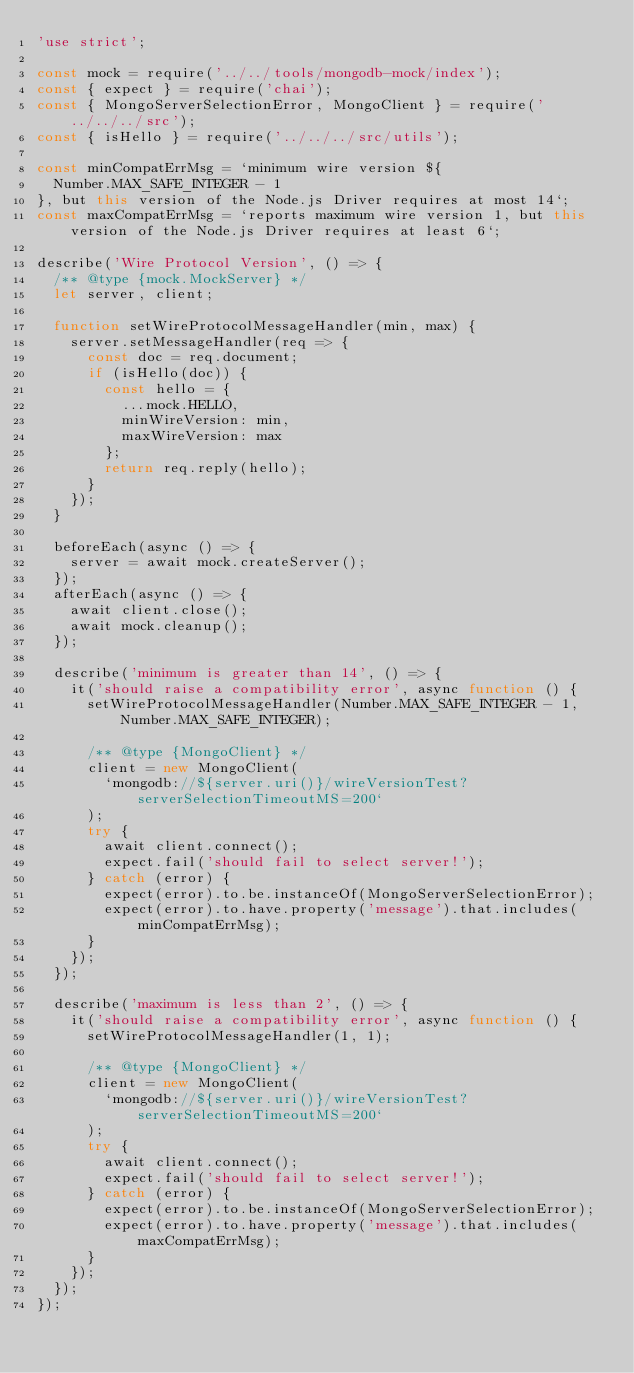<code> <loc_0><loc_0><loc_500><loc_500><_JavaScript_>'use strict';

const mock = require('../../tools/mongodb-mock/index');
const { expect } = require('chai');
const { MongoServerSelectionError, MongoClient } = require('../../../src');
const { isHello } = require('../../../src/utils');

const minCompatErrMsg = `minimum wire version ${
  Number.MAX_SAFE_INTEGER - 1
}, but this version of the Node.js Driver requires at most 14`;
const maxCompatErrMsg = `reports maximum wire version 1, but this version of the Node.js Driver requires at least 6`;

describe('Wire Protocol Version', () => {
  /** @type {mock.MockServer} */
  let server, client;

  function setWireProtocolMessageHandler(min, max) {
    server.setMessageHandler(req => {
      const doc = req.document;
      if (isHello(doc)) {
        const hello = {
          ...mock.HELLO,
          minWireVersion: min,
          maxWireVersion: max
        };
        return req.reply(hello);
      }
    });
  }

  beforeEach(async () => {
    server = await mock.createServer();
  });
  afterEach(async () => {
    await client.close();
    await mock.cleanup();
  });

  describe('minimum is greater than 14', () => {
    it('should raise a compatibility error', async function () {
      setWireProtocolMessageHandler(Number.MAX_SAFE_INTEGER - 1, Number.MAX_SAFE_INTEGER);

      /** @type {MongoClient} */
      client = new MongoClient(
        `mongodb://${server.uri()}/wireVersionTest?serverSelectionTimeoutMS=200`
      );
      try {
        await client.connect();
        expect.fail('should fail to select server!');
      } catch (error) {
        expect(error).to.be.instanceOf(MongoServerSelectionError);
        expect(error).to.have.property('message').that.includes(minCompatErrMsg);
      }
    });
  });

  describe('maximum is less than 2', () => {
    it('should raise a compatibility error', async function () {
      setWireProtocolMessageHandler(1, 1);

      /** @type {MongoClient} */
      client = new MongoClient(
        `mongodb://${server.uri()}/wireVersionTest?serverSelectionTimeoutMS=200`
      );
      try {
        await client.connect();
        expect.fail('should fail to select server!');
      } catch (error) {
        expect(error).to.be.instanceOf(MongoServerSelectionError);
        expect(error).to.have.property('message').that.includes(maxCompatErrMsg);
      }
    });
  });
});
</code> 